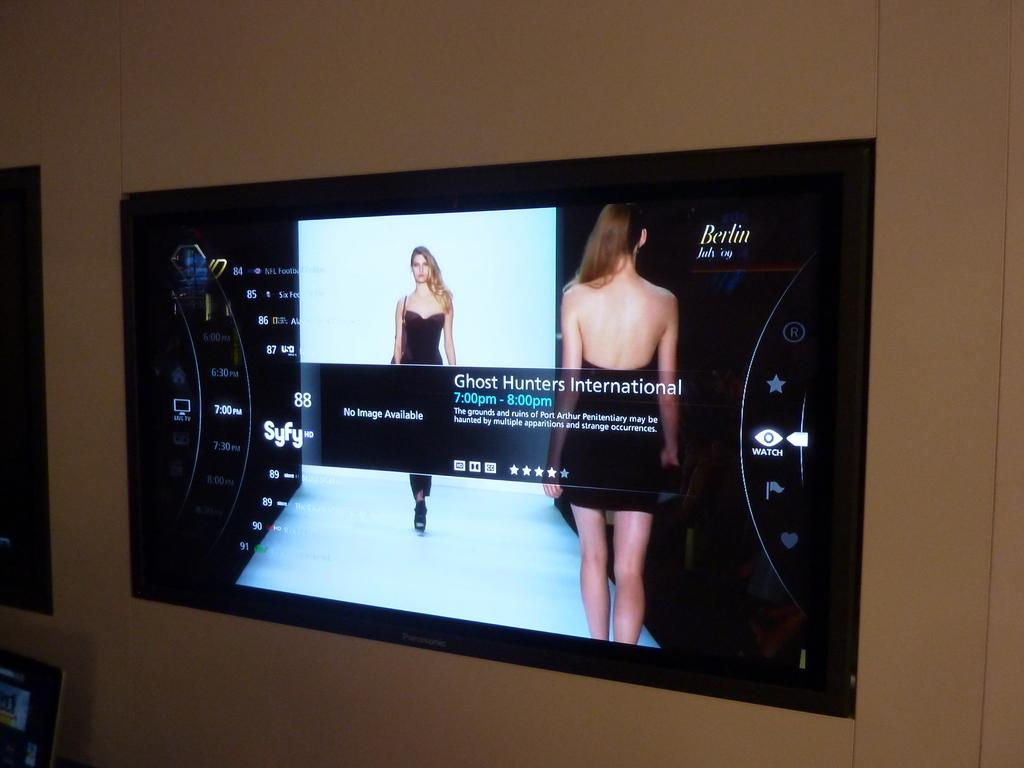Provide a one-sentence caption for the provided image. Television Screen that says Berlin July 09 and says Ghost Hunters International 7:00 PM to 8:00 PM. 